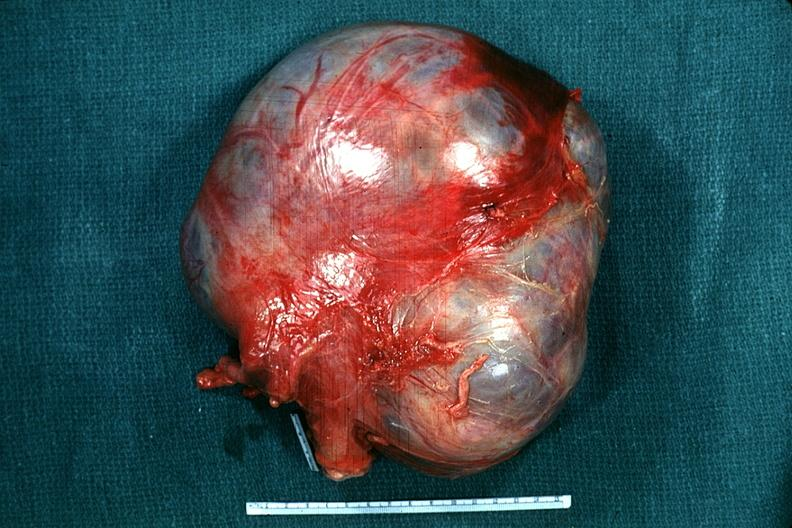what is present?
Answer the question using a single word or phrase. Female reproductive 